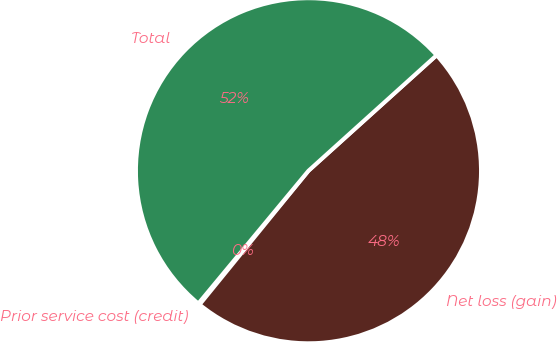Convert chart. <chart><loc_0><loc_0><loc_500><loc_500><pie_chart><fcel>Prior service cost (credit)<fcel>Net loss (gain)<fcel>Total<nl><fcel>0.15%<fcel>47.55%<fcel>52.3%<nl></chart> 